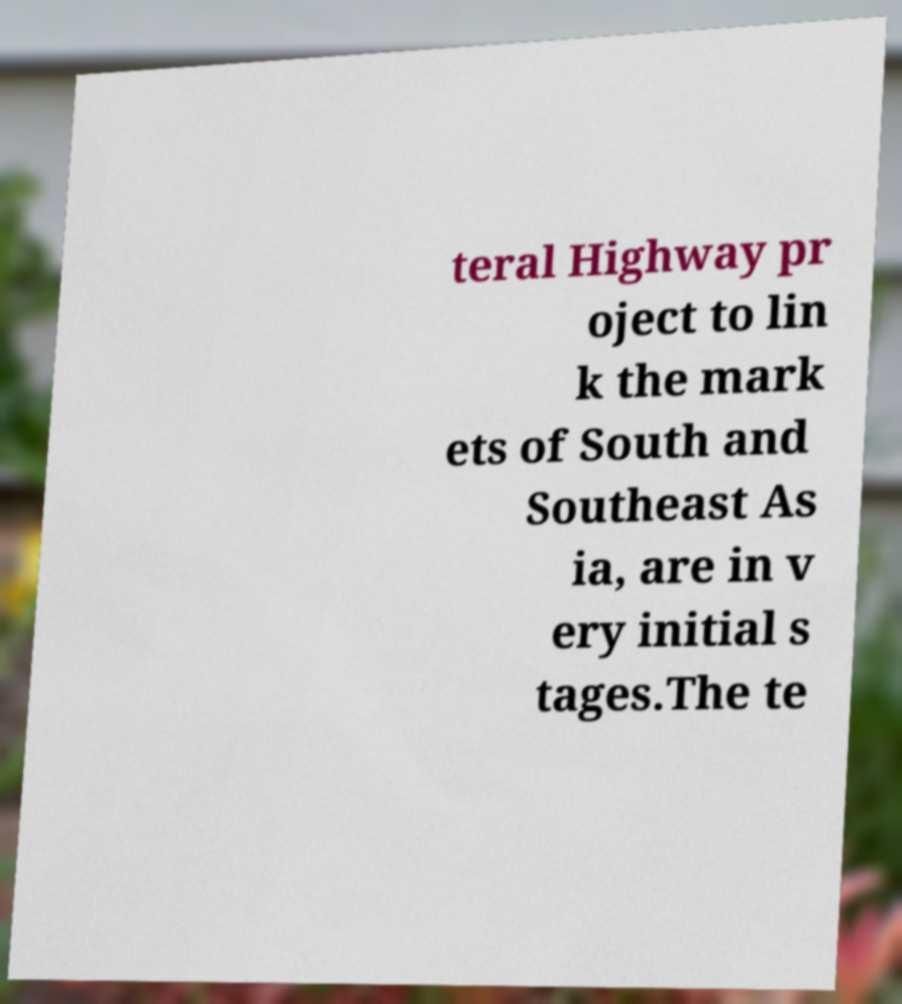I need the written content from this picture converted into text. Can you do that? teral Highway pr oject to lin k the mark ets of South and Southeast As ia, are in v ery initial s tages.The te 